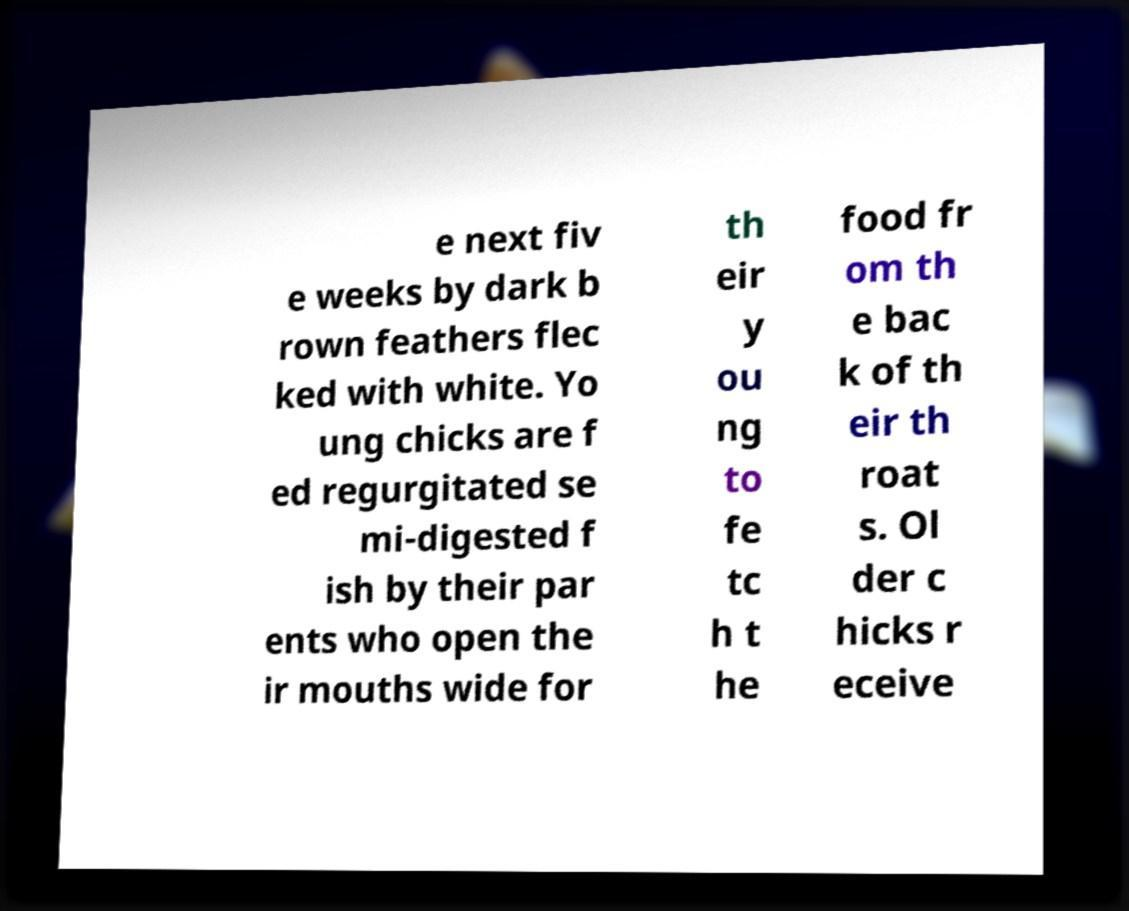Could you assist in decoding the text presented in this image and type it out clearly? e next fiv e weeks by dark b rown feathers flec ked with white. Yo ung chicks are f ed regurgitated se mi-digested f ish by their par ents who open the ir mouths wide for th eir y ou ng to fe tc h t he food fr om th e bac k of th eir th roat s. Ol der c hicks r eceive 